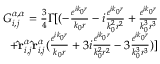Convert formula to latex. <formula><loc_0><loc_0><loc_500><loc_500>\begin{array} { r } { G _ { i , j } ^ { \alpha , \alpha } = \frac { 3 } { 4 } \Gamma [ ( - \frac { e ^ { i k _ { 0 } r } } { k _ { 0 } r } - i \frac { e ^ { i k _ { 0 } r } } { k _ { 0 } ^ { 2 } r ^ { 2 } } + \frac { e ^ { i k _ { 0 } r } } { k _ { 0 } ^ { 3 } r ^ { 3 } } } \\ { + \hat { r } _ { i , j } ^ { \alpha } \hat { r } _ { i , j } ^ { \alpha } ( \frac { e ^ { i k _ { 0 } r } } { k _ { 0 } r } + 3 i \frac { e ^ { i k _ { 0 } r } } { k _ { 0 } ^ { 2 } r ^ { 2 } } - 3 \frac { e ^ { i k _ { 0 } r } } { k _ { 0 } ^ { 3 } r ^ { 3 } } ) ] } \end{array}</formula> 